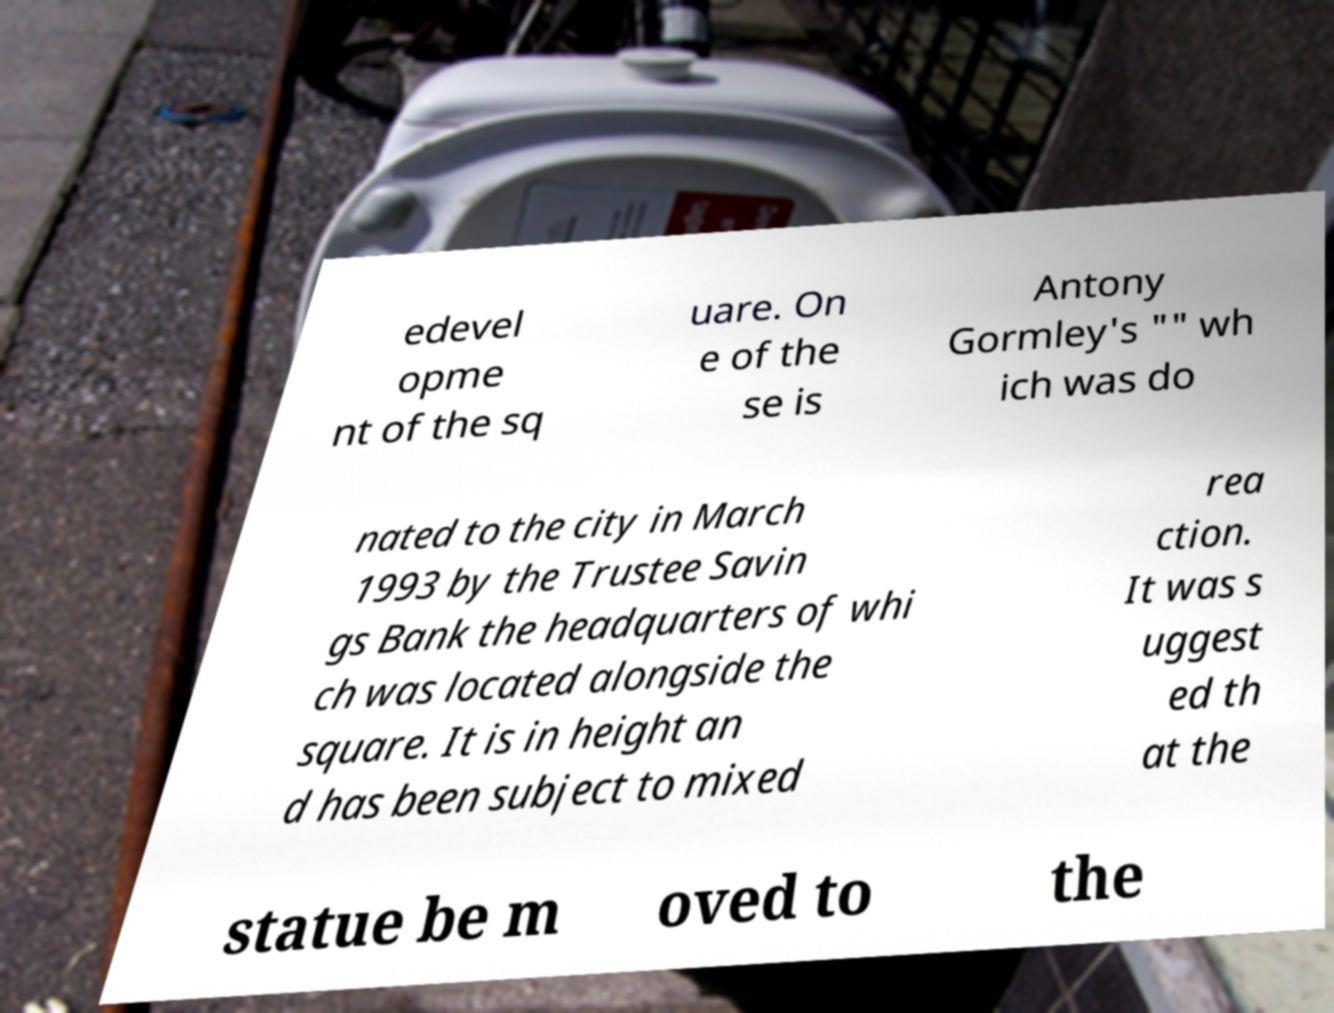What messages or text are displayed in this image? I need them in a readable, typed format. edevel opme nt of the sq uare. On e of the se is Antony Gormley's "" wh ich was do nated to the city in March 1993 by the Trustee Savin gs Bank the headquarters of whi ch was located alongside the square. It is in height an d has been subject to mixed rea ction. It was s uggest ed th at the statue be m oved to the 